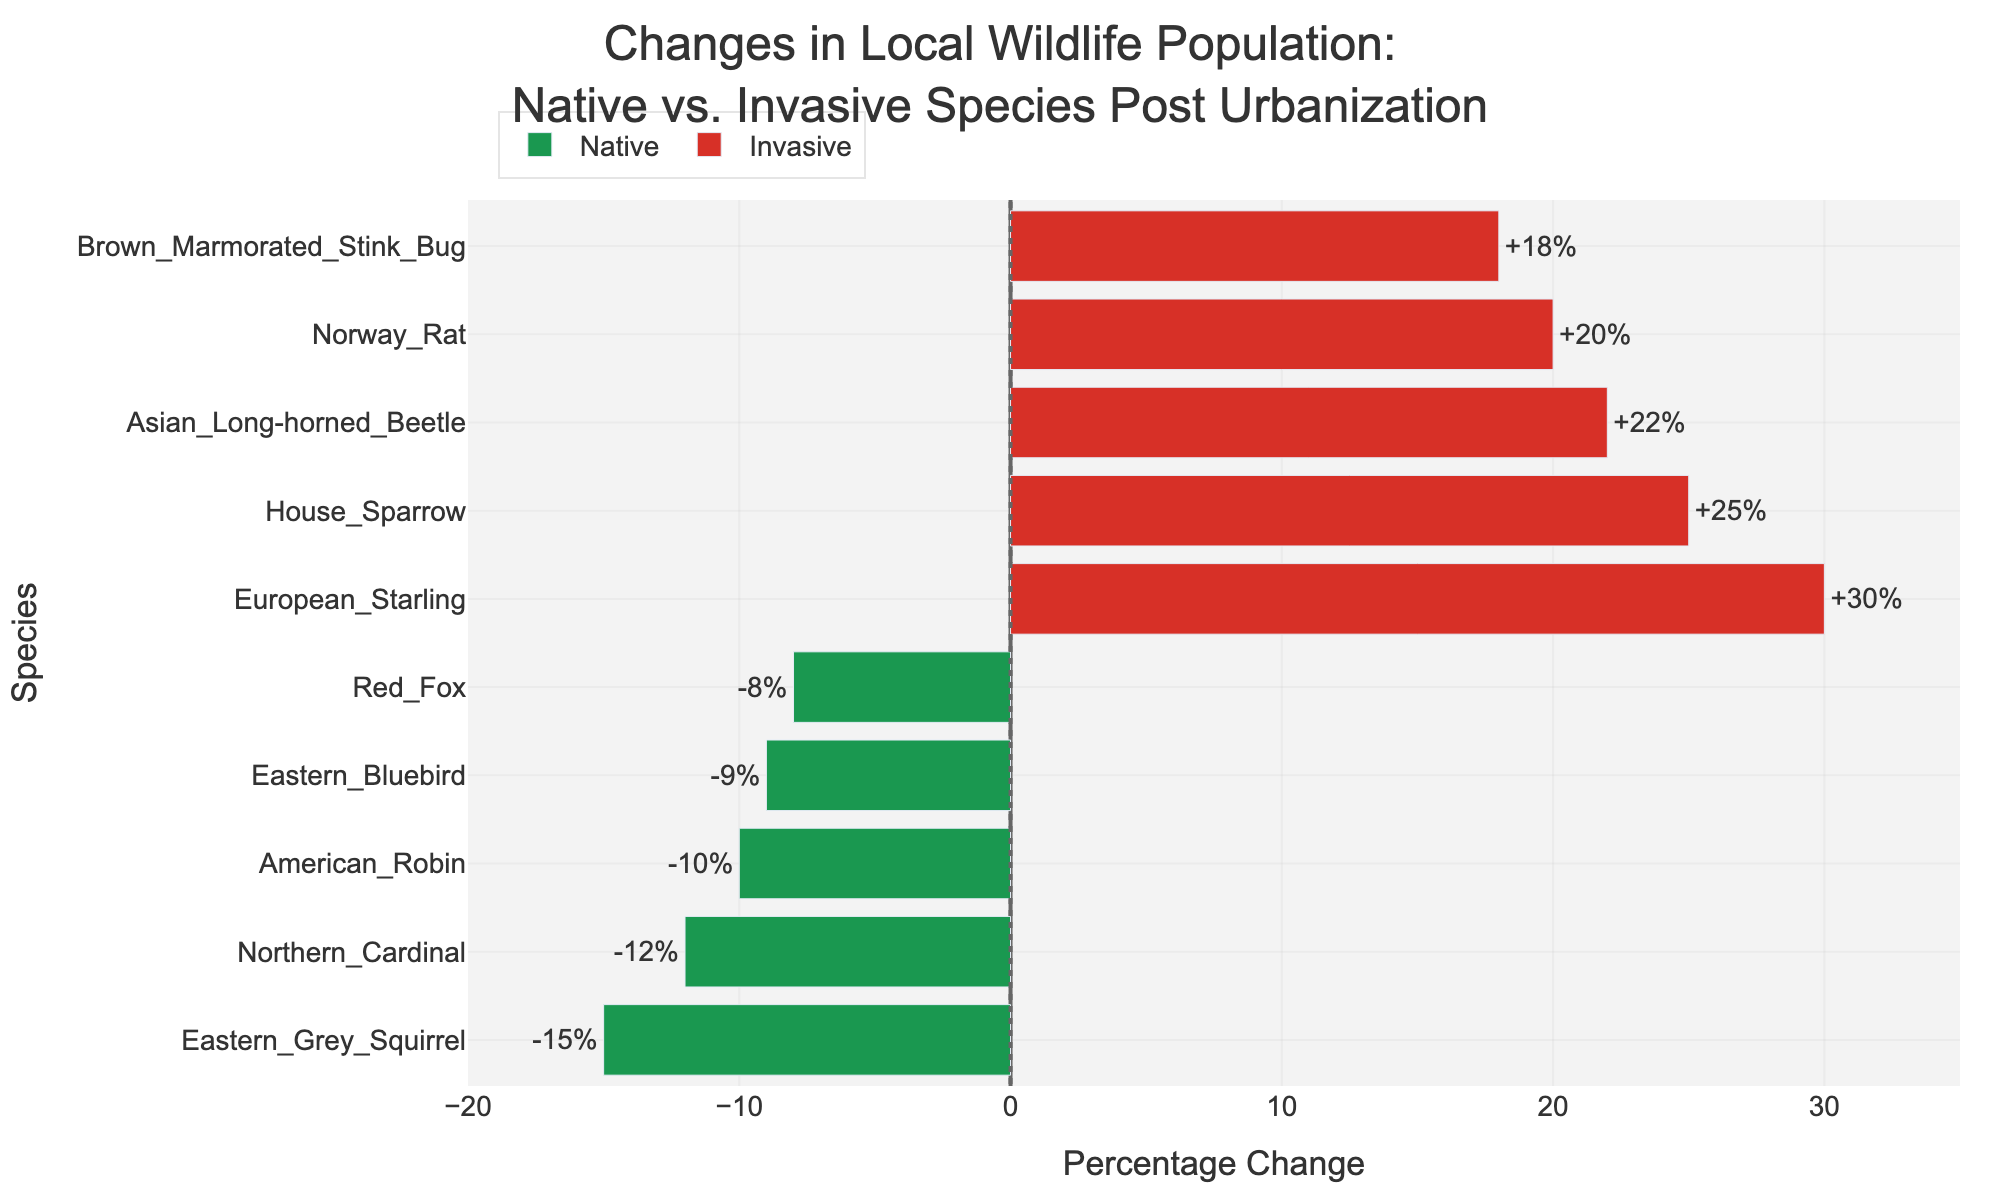What's the percentage change for the House Sparrow? Look for the House Sparrow bar under the "Invasive" category. The associated percentage change is shown as part of the label.
Answer: +25% Which species has the highest percentage change? Identify the bar that extends the furthest to the right. This bar represents the European Starling in the "Invasive" category with a percentage change of +30%.
Answer: European Starling What's the difference in percentage change between the European Starling and the American Robin? European Starling has +30%, and American Robin has -10%. Calculate the difference: 30 - (-10) = 30 + 10 = 40.
Answer: 40 Between the Red Fox and the Norway Rat, which species shows a greater change? Compare the bars for Red Fox and Norway Rat. Red Fox shows -8%, whereas Norway Rat shows +20%. Thus, Norway Rat has a greater change.
Answer: Norway Rat What's the combined average percentage change for the native species? Average is calculated by summing the percentage changes of native species and dividing by the number of species: (-15) + (-10) + (-8) + (-12) + (-9) = -54; -54 / 5 = -10.8.
Answer: -10.8 How many invasive species show a percentage change greater than 20%? Inspect the bars labeled under the "Invasive" category and count those greater than 20%. European Starling (+30%), Asian Long-horned Beetle (+22%) = 2 species.
Answer: 2 Is there any native species with a percentage change less than -15%? Look for bars in the "Native" category and check if any have less than -15%. All values are -15% or higher.
Answer: No Which species, according to the color coding, has benefited the most from urbanization? The red bars represent invasive species. The longest red bar belongs to European Starling, indicating it has benefited the most with a +30% change.
Answer: European Starling What's the percentage change difference between the Eastern Bluebird and Brown Marmorated Stink Bug? Eastern Bluebird has -9%, and Brown Marmorated Stink Bug has +18%. Calculate the difference: 18 - (-9) = 18 + 9 = 27.
Answer: 27 How does the change in Northern Cardinal compare to the House Sparrow? Northern Cardinal has a -12% change, while House Sparrow has a +25% change. This shows that while the Northern Cardinal's population decreased by 12%, House Sparrow's population increased by 25%.
Answer: Northern Cardinal: -12%; House Sparrow: +25% 